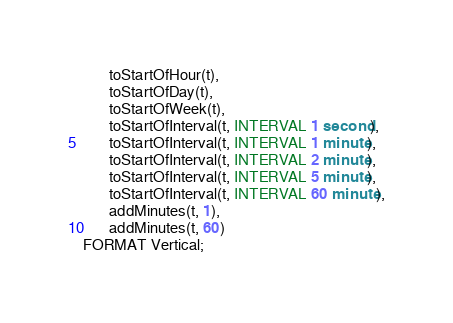Convert code to text. <code><loc_0><loc_0><loc_500><loc_500><_SQL_>       toStartOfHour(t),
       toStartOfDay(t),
       toStartOfWeek(t),
       toStartOfInterval(t, INTERVAL 1 second),
       toStartOfInterval(t, INTERVAL 1 minute),
       toStartOfInterval(t, INTERVAL 2 minute),
       toStartOfInterval(t, INTERVAL 5 minute),
       toStartOfInterval(t, INTERVAL 60 minute),
       addMinutes(t, 1),
       addMinutes(t, 60)
FORMAT Vertical;
</code> 